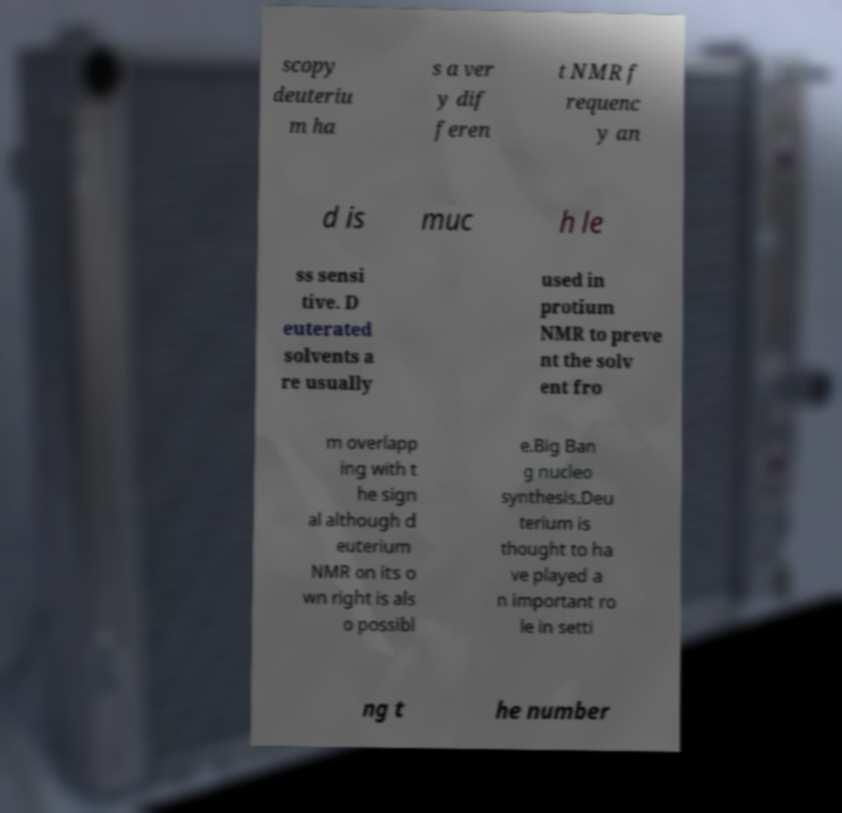Can you accurately transcribe the text from the provided image for me? scopy deuteriu m ha s a ver y dif feren t NMR f requenc y an d is muc h le ss sensi tive. D euterated solvents a re usually used in protium NMR to preve nt the solv ent fro m overlapp ing with t he sign al although d euterium NMR on its o wn right is als o possibl e.Big Ban g nucleo synthesis.Deu terium is thought to ha ve played a n important ro le in setti ng t he number 